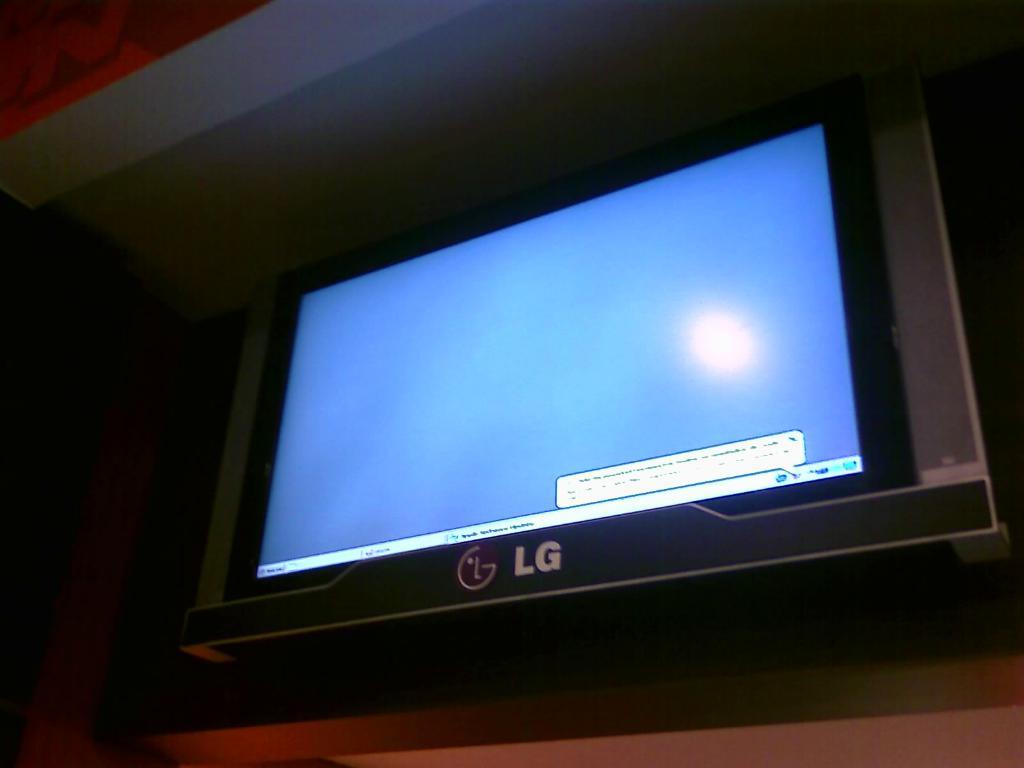Who is the manufacturer of this tv?
Offer a very short reply. Lg. Who is the manufacturer of the tv?
Offer a very short reply. Lg. 